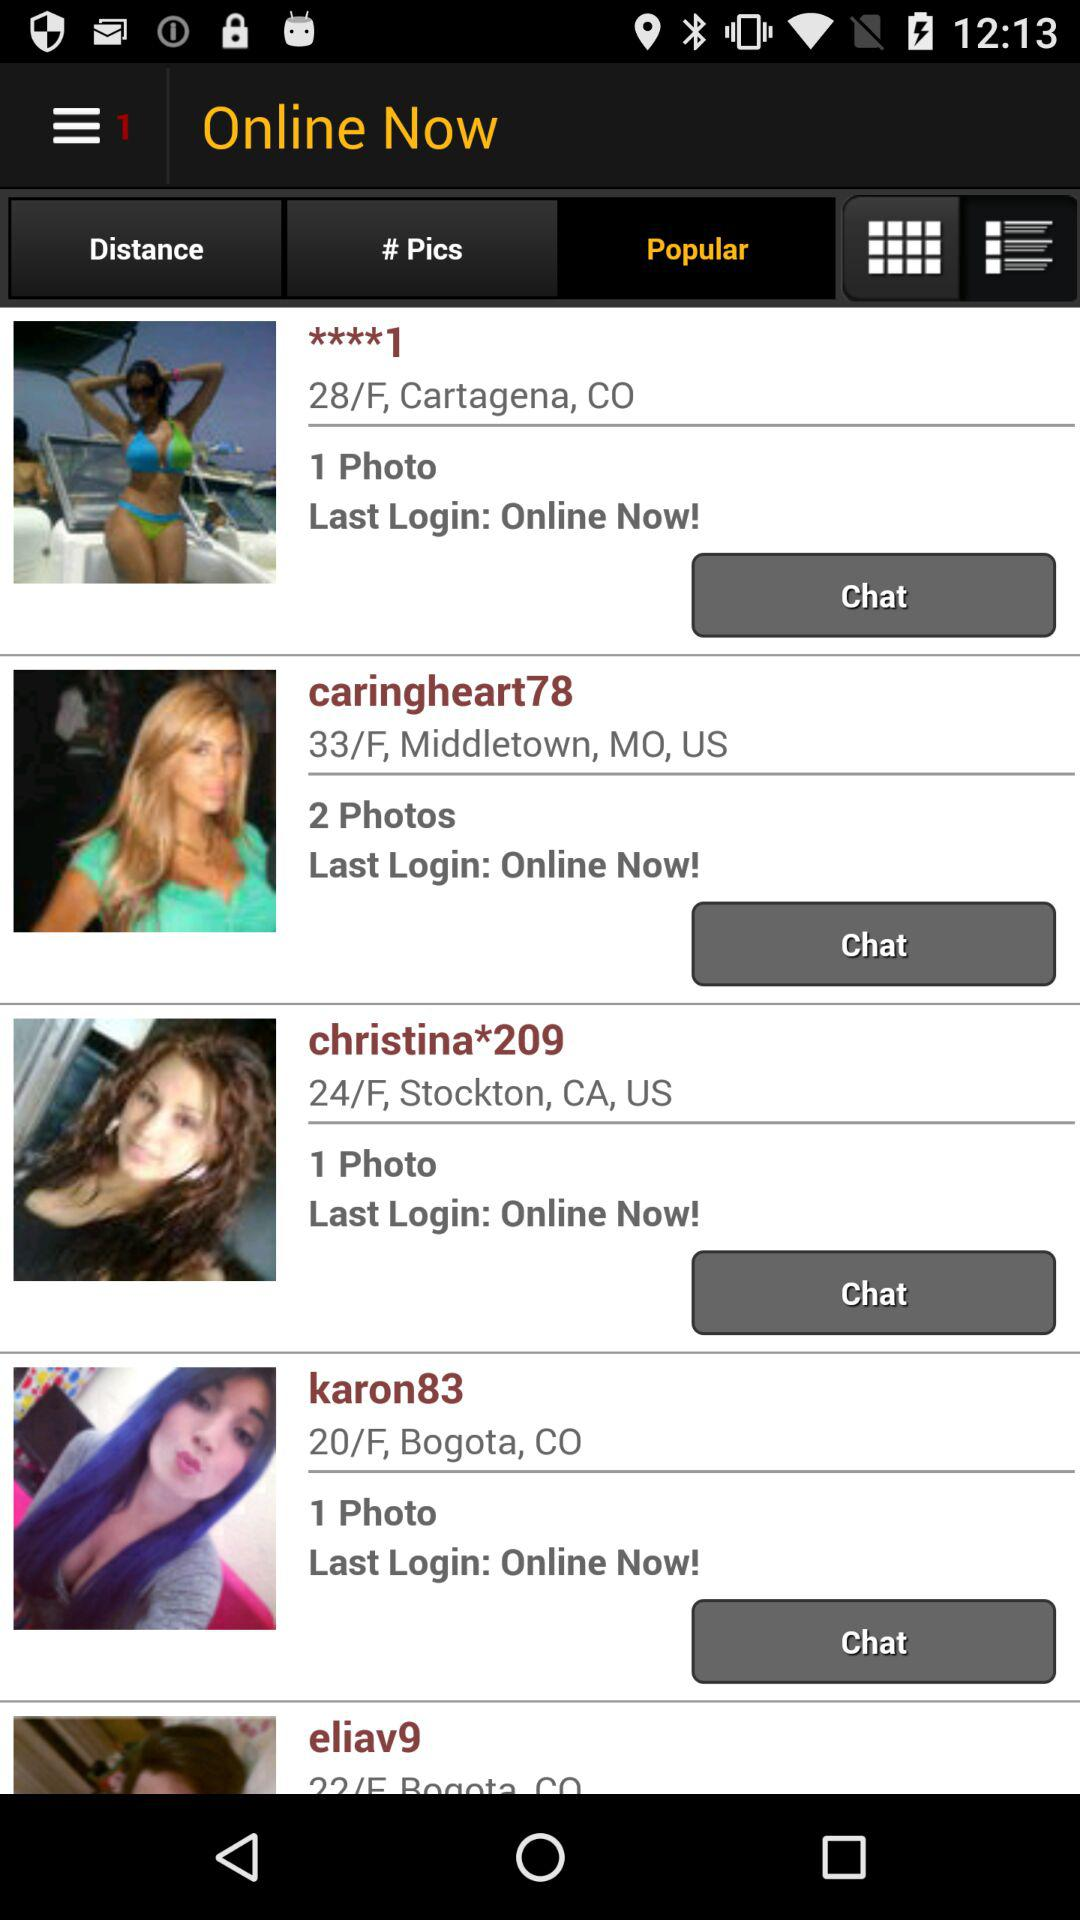What's the location of "caringheart78"? The location is 33/F, Middletown, MO, US. 